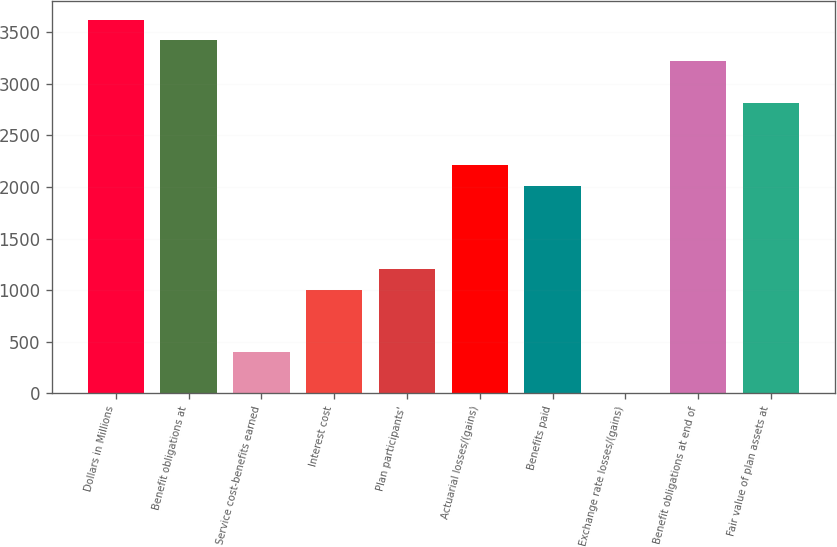Convert chart. <chart><loc_0><loc_0><loc_500><loc_500><bar_chart><fcel>Dollars in Millions<fcel>Benefit obligations at<fcel>Service cost-benefits earned<fcel>Interest cost<fcel>Plan participants'<fcel>Actuarial losses/(gains)<fcel>Benefits paid<fcel>Exchange rate losses/(gains)<fcel>Benefit obligations at end of<fcel>Fair value of plan assets at<nl><fcel>3620.8<fcel>3419.7<fcel>403.2<fcel>1006.5<fcel>1207.6<fcel>2213.1<fcel>2012<fcel>1<fcel>3218.6<fcel>2816.4<nl></chart> 